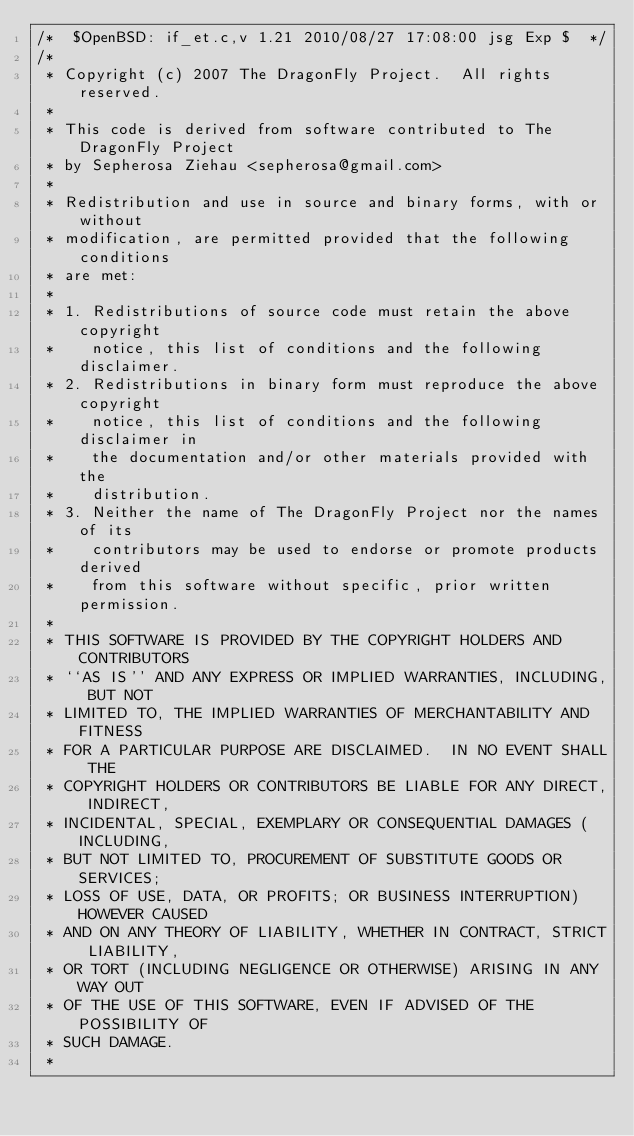Convert code to text. <code><loc_0><loc_0><loc_500><loc_500><_C_>/*	$OpenBSD: if_et.c,v 1.21 2010/08/27 17:08:00 jsg Exp $	*/
/*
 * Copyright (c) 2007 The DragonFly Project.  All rights reserved.
 * 
 * This code is derived from software contributed to The DragonFly Project
 * by Sepherosa Ziehau <sepherosa@gmail.com>
 * 
 * Redistribution and use in source and binary forms, with or without
 * modification, are permitted provided that the following conditions
 * are met:
 * 
 * 1. Redistributions of source code must retain the above copyright
 *    notice, this list of conditions and the following disclaimer.
 * 2. Redistributions in binary form must reproduce the above copyright
 *    notice, this list of conditions and the following disclaimer in
 *    the documentation and/or other materials provided with the
 *    distribution.
 * 3. Neither the name of The DragonFly Project nor the names of its
 *    contributors may be used to endorse or promote products derived
 *    from this software without specific, prior written permission.
 * 
 * THIS SOFTWARE IS PROVIDED BY THE COPYRIGHT HOLDERS AND CONTRIBUTORS
 * ``AS IS'' AND ANY EXPRESS OR IMPLIED WARRANTIES, INCLUDING, BUT NOT
 * LIMITED TO, THE IMPLIED WARRANTIES OF MERCHANTABILITY AND FITNESS
 * FOR A PARTICULAR PURPOSE ARE DISCLAIMED.  IN NO EVENT SHALL THE
 * COPYRIGHT HOLDERS OR CONTRIBUTORS BE LIABLE FOR ANY DIRECT, INDIRECT,
 * INCIDENTAL, SPECIAL, EXEMPLARY OR CONSEQUENTIAL DAMAGES (INCLUDING,
 * BUT NOT LIMITED TO, PROCUREMENT OF SUBSTITUTE GOODS OR SERVICES;
 * LOSS OF USE, DATA, OR PROFITS; OR BUSINESS INTERRUPTION) HOWEVER CAUSED
 * AND ON ANY THEORY OF LIABILITY, WHETHER IN CONTRACT, STRICT LIABILITY,
 * OR TORT (INCLUDING NEGLIGENCE OR OTHERWISE) ARISING IN ANY WAY OUT
 * OF THE USE OF THIS SOFTWARE, EVEN IF ADVISED OF THE POSSIBILITY OF
 * SUCH DAMAGE.
 * </code> 